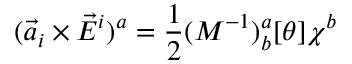<formula> <loc_0><loc_0><loc_500><loc_500>( { \vec { a } } _ { i } \times { \vec { E } } ^ { i } ) ^ { a } = \frac { 1 } { 2 } ( M ^ { - 1 } ) _ { b } ^ { a } [ \theta ] \chi ^ { b }</formula> 